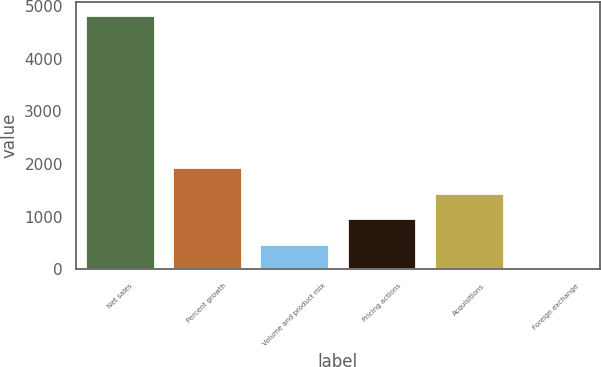Convert chart to OTSL. <chart><loc_0><loc_0><loc_500><loc_500><bar_chart><fcel>Net sales<fcel>Percent growth<fcel>Volume and product mix<fcel>Pricing actions<fcel>Acquisitions<fcel>Foreign exchange<nl><fcel>4834.1<fcel>1934.06<fcel>484.04<fcel>967.38<fcel>1450.72<fcel>0.7<nl></chart> 